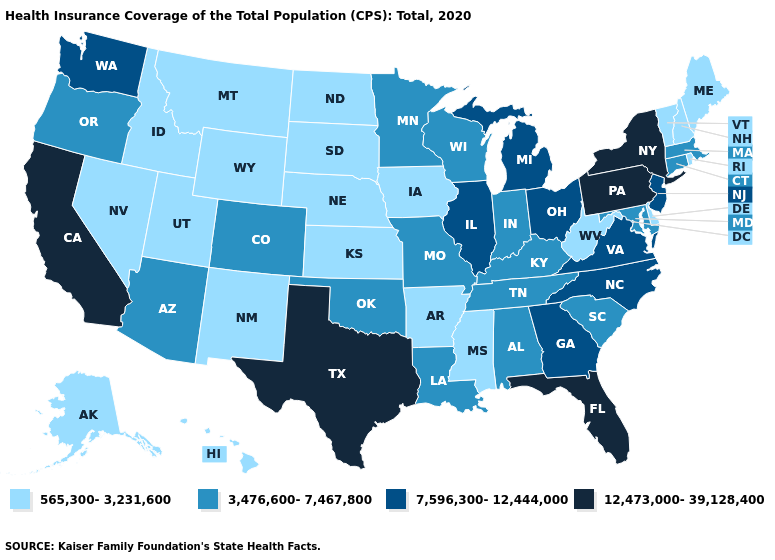What is the value of Kansas?
Keep it brief. 565,300-3,231,600. Which states hav the highest value in the MidWest?
Give a very brief answer. Illinois, Michigan, Ohio. Among the states that border Maryland , which have the lowest value?
Answer briefly. Delaware, West Virginia. Name the states that have a value in the range 7,596,300-12,444,000?
Be succinct. Georgia, Illinois, Michigan, New Jersey, North Carolina, Ohio, Virginia, Washington. Which states have the lowest value in the West?
Be succinct. Alaska, Hawaii, Idaho, Montana, Nevada, New Mexico, Utah, Wyoming. What is the value of South Carolina?
Quick response, please. 3,476,600-7,467,800. Among the states that border New Hampshire , does Massachusetts have the lowest value?
Keep it brief. No. What is the highest value in the USA?
Concise answer only. 12,473,000-39,128,400. Does Maine have the same value as New Hampshire?
Be succinct. Yes. Does Nevada have the highest value in the West?
Keep it brief. No. Does the first symbol in the legend represent the smallest category?
Answer briefly. Yes. What is the value of New Jersey?
Be succinct. 7,596,300-12,444,000. What is the value of Indiana?
Quick response, please. 3,476,600-7,467,800. Among the states that border Florida , does Alabama have the lowest value?
Quick response, please. Yes. What is the lowest value in the South?
Quick response, please. 565,300-3,231,600. 